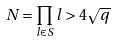Convert formula to latex. <formula><loc_0><loc_0><loc_500><loc_500>N = \prod _ { l \in S } l > 4 \sqrt { q }</formula> 